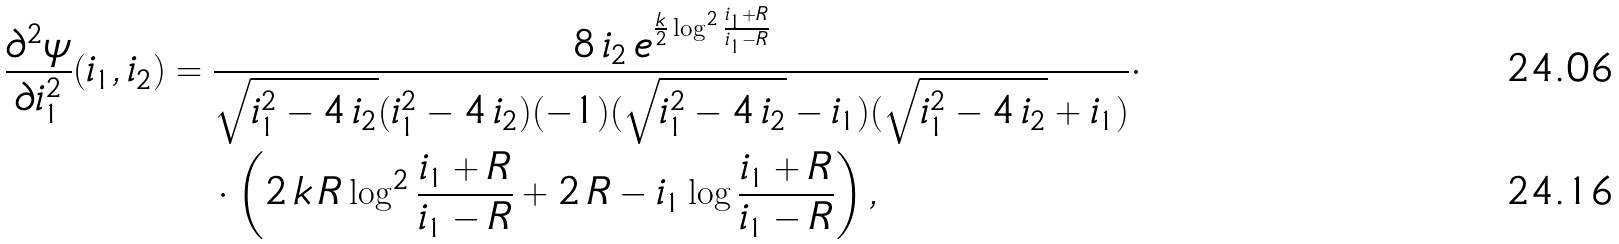Convert formula to latex. <formula><loc_0><loc_0><loc_500><loc_500>\frac { \partial ^ { 2 } \psi } { \partial i _ { 1 } ^ { 2 } } ( i _ { 1 } , i _ { 2 } ) & = \frac { 8 \, i _ { 2 } \, e ^ { \frac { k } { 2 } \log ^ { 2 } \frac { i _ { 1 } + R } { i _ { 1 } - R } } } { \sqrt { i _ { 1 } ^ { 2 } - 4 \, i _ { 2 } } ( i _ { 1 } ^ { 2 } - 4 \, i _ { 2 } ) ( - 1 ) ( \sqrt { i _ { 1 } ^ { 2 } - 4 \, i _ { 2 } } - i _ { 1 } ) ( \sqrt { i _ { 1 } ^ { 2 } - 4 \, i _ { 2 } } + i _ { 1 } ) } \cdot \\ & \quad \cdot \left ( 2 \, k \, R \log ^ { 2 } \frac { i _ { 1 } + R } { i _ { 1 } - R } + 2 \, R - i _ { 1 } \log \frac { i _ { 1 } + R } { i _ { 1 } - R } \right ) ,</formula> 